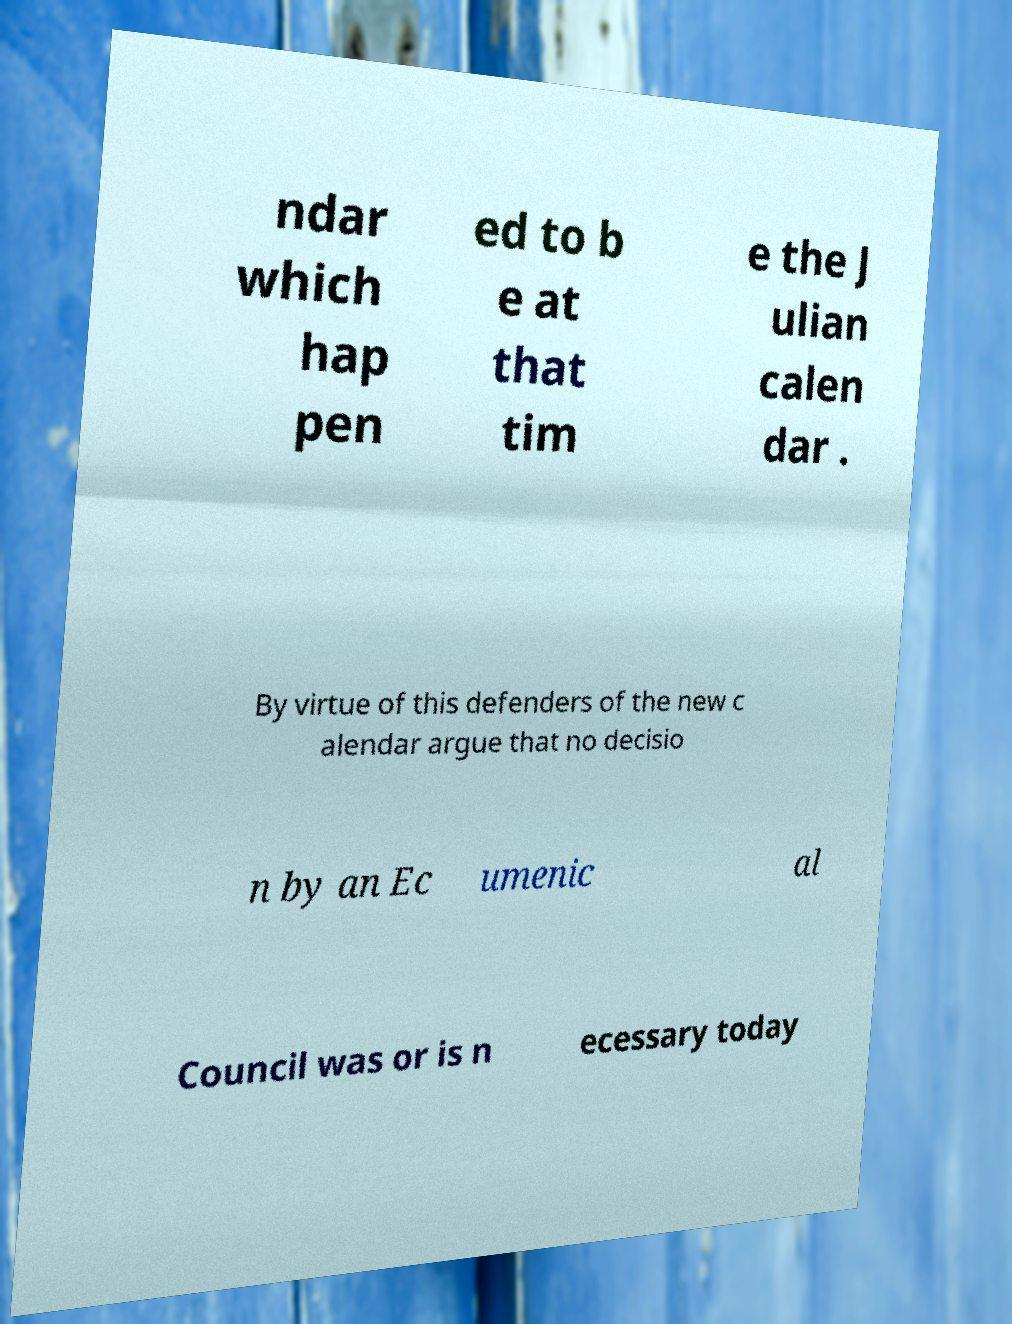I need the written content from this picture converted into text. Can you do that? ndar which hap pen ed to b e at that tim e the J ulian calen dar . By virtue of this defenders of the new c alendar argue that no decisio n by an Ec umenic al Council was or is n ecessary today 